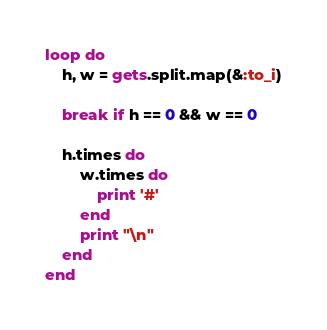Convert code to text. <code><loc_0><loc_0><loc_500><loc_500><_Ruby_>loop do
	h, w = gets.split.map(&:to_i)
	
	break if h == 0 && w == 0

	h.times do
		w.times do
			print '#'
		end
		print "\n"
	end
end</code> 